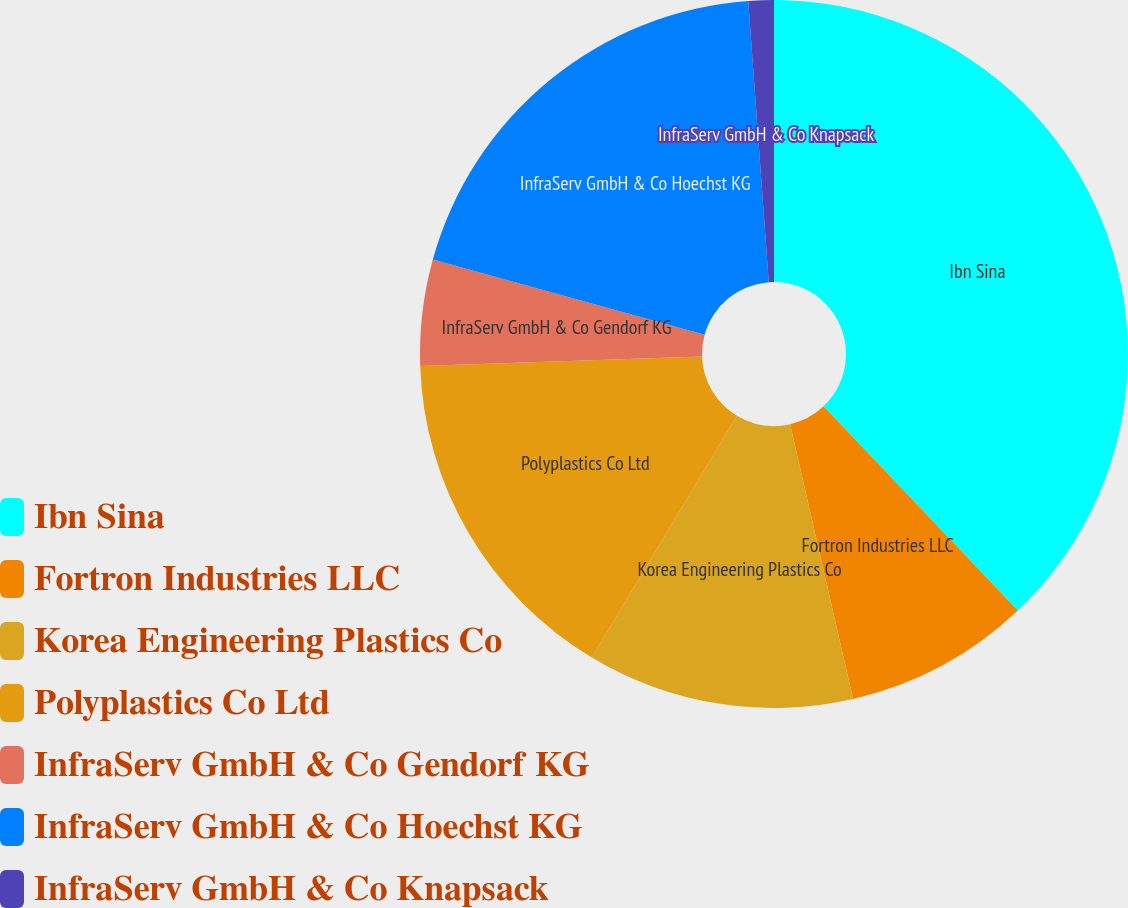Convert chart. <chart><loc_0><loc_0><loc_500><loc_500><pie_chart><fcel>Ibn Sina<fcel>Fortron Industries LLC<fcel>Korea Engineering Plastics Co<fcel>Polyplastics Co Ltd<fcel>InfraServ GmbH & Co Gendorf KG<fcel>InfraServ GmbH & Co Hoechst KG<fcel>InfraServ GmbH & Co Knapsack<nl><fcel>37.91%<fcel>8.51%<fcel>12.19%<fcel>15.86%<fcel>4.84%<fcel>19.54%<fcel>1.16%<nl></chart> 